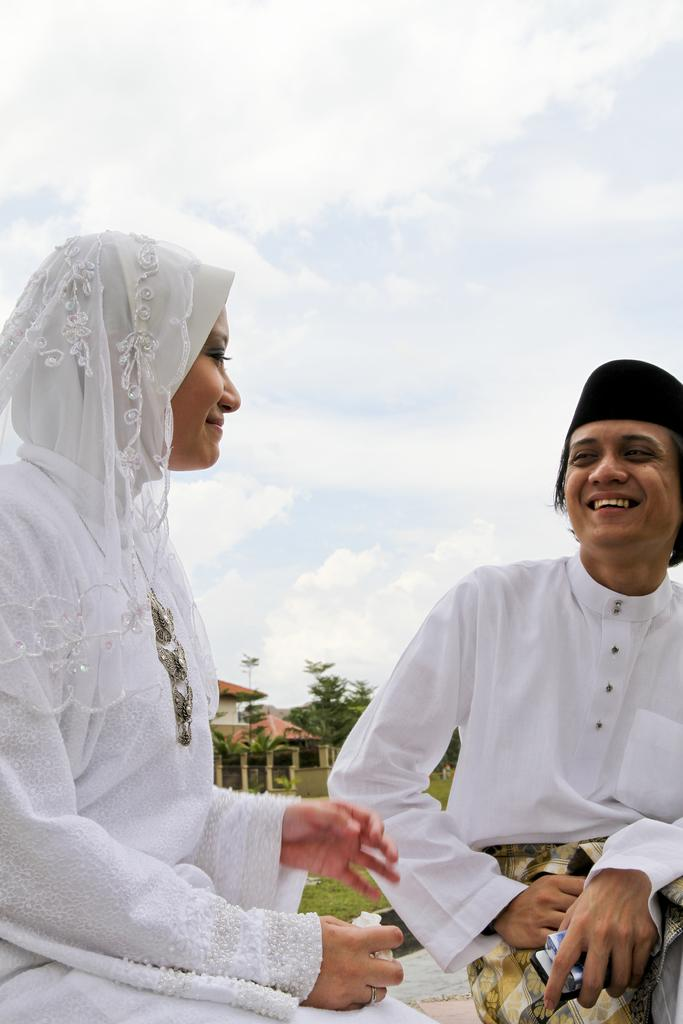Who are the two people in the center of the image? There is a man and a woman sitting in the center of the image. What can be seen in the background of the image? There is a house, trees, grass, and the sky visible in the background of the image. What is the condition of the sky in the image? The sky is visible in the background of the image, and there are clouds present. What type of silver object is being used by the man and woman in the image? There is no silver object present in the image. What belief system do the man and woman in the image follow? There is no information about the man and woman's belief system in the image. 